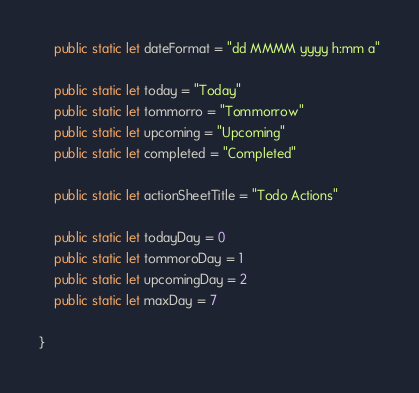Convert code to text. <code><loc_0><loc_0><loc_500><loc_500><_Swift_>    public static let dateFormat = "dd MMMM yyyy h:mm a"
    
    public static let today = "Today"
    public static let tommorro = "Tommorrow"
    public static let upcoming = "Upcoming"
    public static let completed = "Completed"
    
    public static let actionSheetTitle = "Todo Actions"
    
    public static let todayDay = 0
    public static let tommoroDay = 1
    public static let upcomingDay = 2
    public static let maxDay = 7
    
}
</code> 